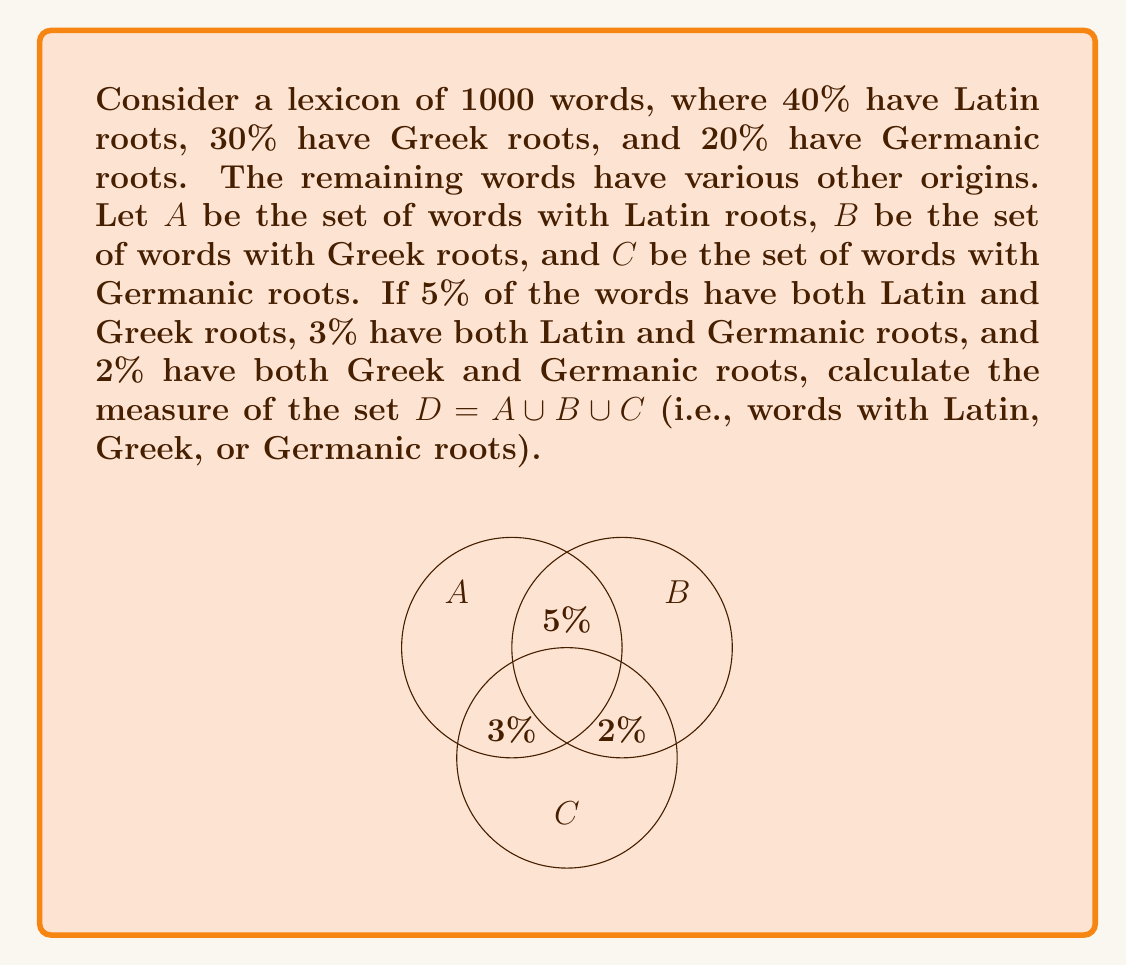Could you help me with this problem? Let's approach this step-by-step using set theory and the principle of inclusion-exclusion:

1) First, let's define our universal set U as all 1000 words.

2) We're given:
   |A| = 40% of U = 0.4 * 1000 = 400
   |B| = 30% of U = 0.3 * 1000 = 300
   |C| = 20% of U = 0.2 * 1000 = 200

3) We're also given:
   |A ∩ B| = 5% of U = 0.05 * 1000 = 50
   |A ∩ C| = 3% of U = 0.03 * 1000 = 30
   |B ∩ C| = 2% of U = 0.02 * 1000 = 20

4) To find |D| = |A ∪ B ∪ C|, we use the principle of inclusion-exclusion:

   |A ∪ B ∪ C| = |A| + |B| + |C| - |A ∩ B| - |A ∩ C| - |B ∩ C| + |A ∩ B ∩ C|

5) We know all values except |A ∩ B ∩ C|. Let's call this value x.

6) Substituting the known values:

   |D| = 400 + 300 + 200 - 50 - 30 - 20 + x

7) Simplifying:

   |D| = 800 - x

8) Now, we need to find x. We can use the fact that |D| must be less than or equal to 1000 (the total number of words):

   800 - x ≤ 1000
   -x ≤ 200
   x ≥ -200

9) Since x represents the number of words in all three sets, it can't be negative. The smallest possible value for x is 0.

10) Therefore, the maximum value for |D| is when x = 0:

    |D| = 800 - 0 = 800

Thus, the measure of set D is 800 words, or 0.8 of the total lexicon.
Answer: 800 words or 0.8 